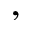<formula> <loc_0><loc_0><loc_500><loc_500>,</formula> 